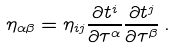<formula> <loc_0><loc_0><loc_500><loc_500>\eta _ { \alpha \beta } = \eta _ { i j } \frac { \partial t ^ { i } } { \partial \tau ^ { \alpha } } \frac { \partial t ^ { j } } { \partial \tau ^ { \beta } } \, .</formula> 